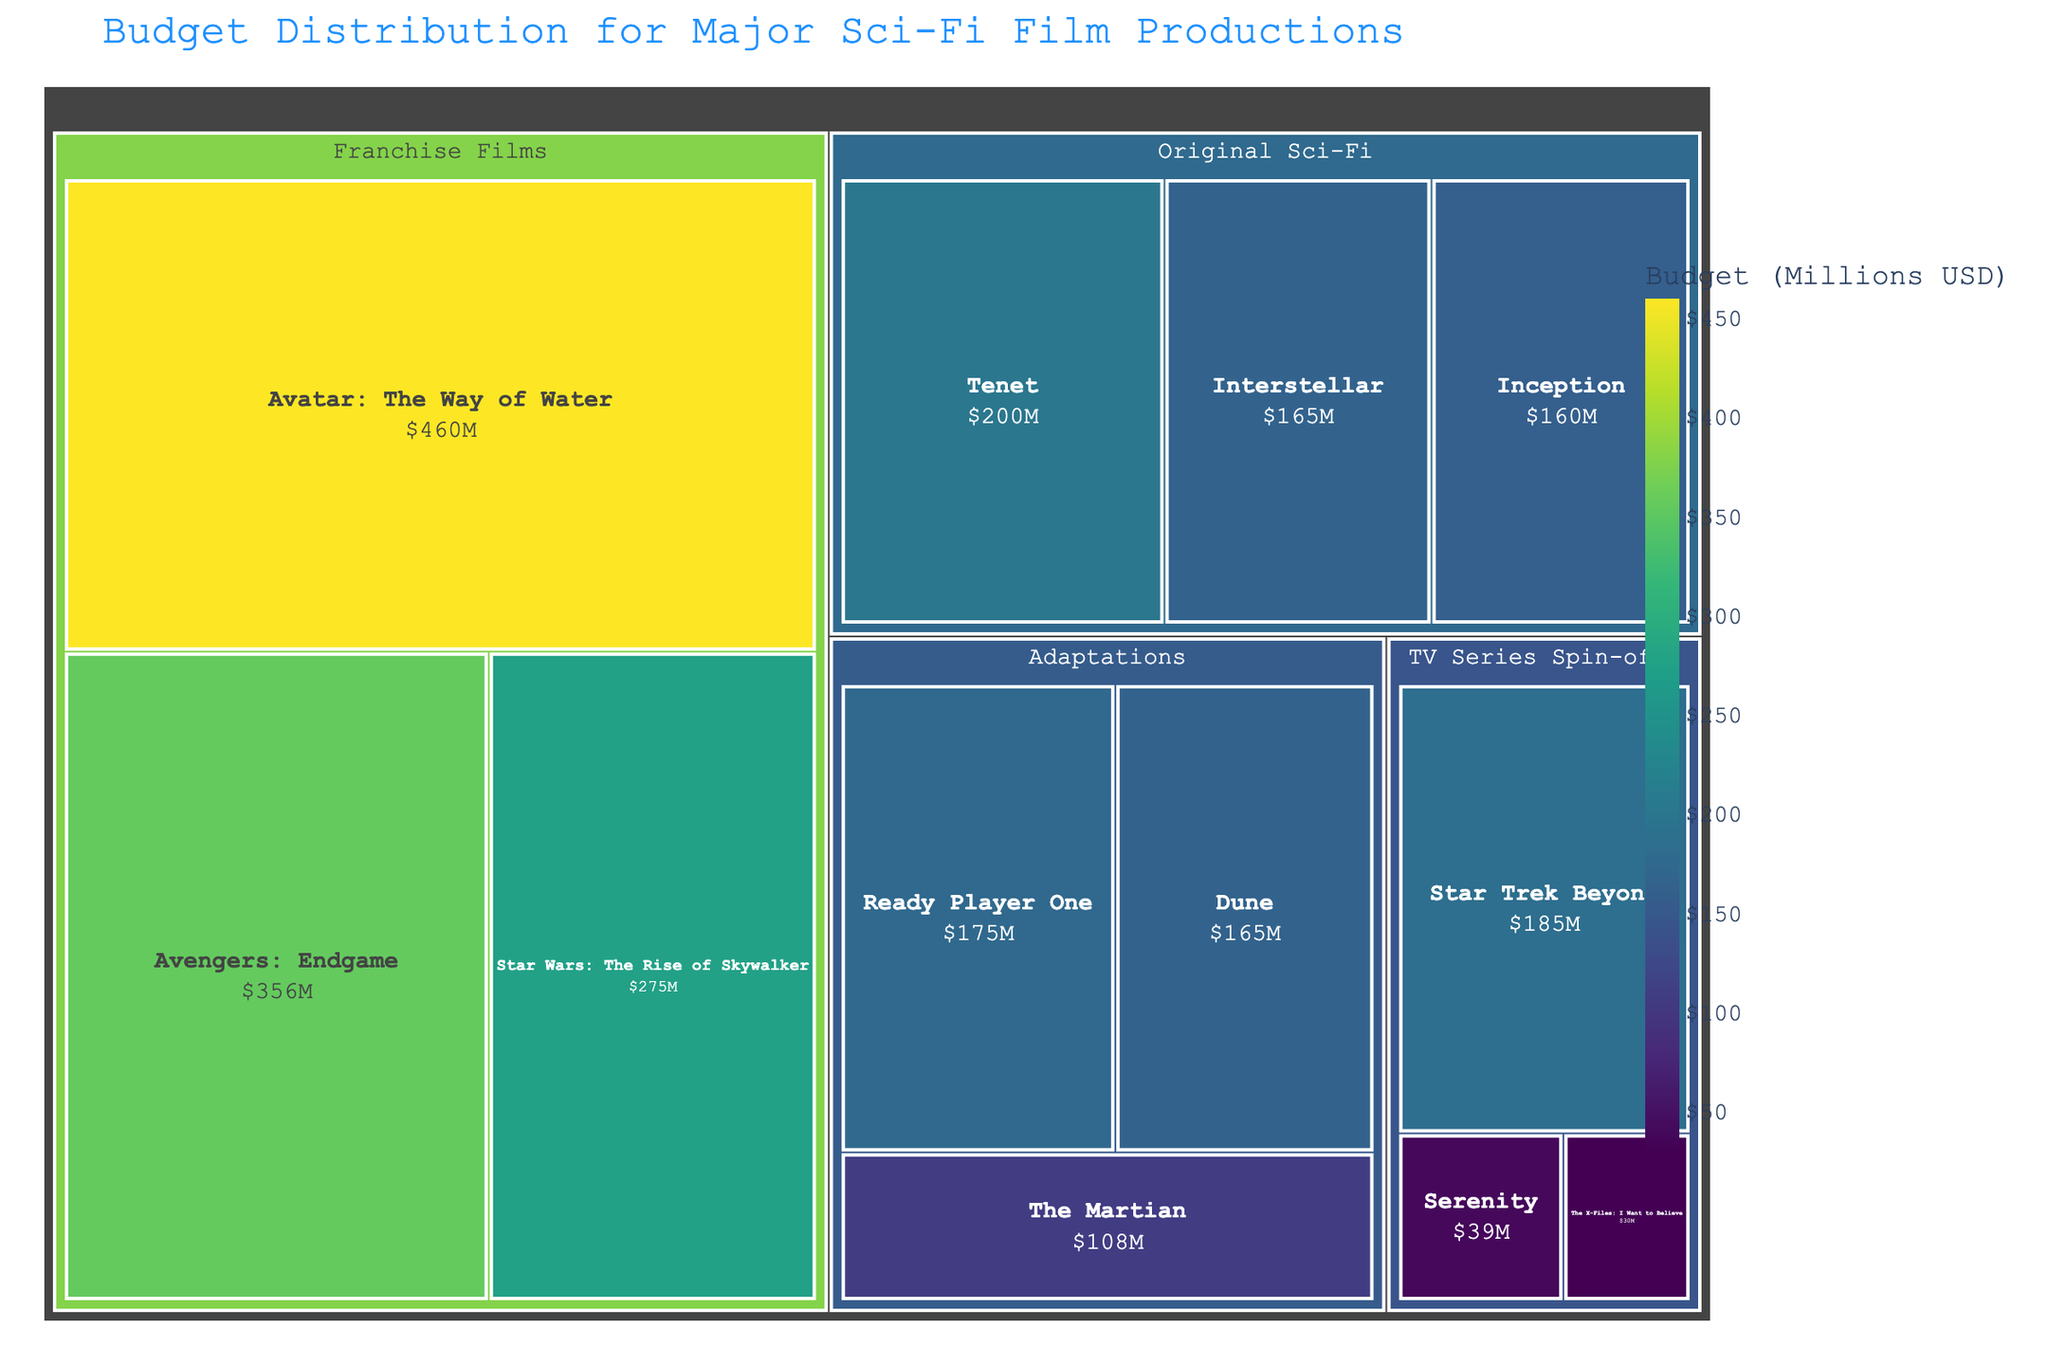What is the title of the Treemap? The title is usually displayed prominently at the top of the Treemap figure. In this case, it helps viewers immediately understand the subject of the visualization without needing to look at the details.
Answer: "Budget Distribution for Major Sci-Fi Film Productions" Which film in the "TV Series Spin-offs" category has the lowest budget? Viewing the treemap, the smallest tile within "TV Series Spin-offs" represents the film with the lowest budget in that category.
Answer: "The X-Files: I Want to Believe" What color scale is used to depict budget values in the Treemap? The color scale is specified by how the values are represented visually. In this case, it utilizes a scale commonly labeled in the figure's legend.
Answer: Viridis What is the budget allocation for "Avatar: The Way of Water"? The budget for each film is shown within the corresponding tile. Locate "Avatar: The Way of Water" in the "Franchise Films" category to get the budget value.
Answer: $460M What is the total budget for films in the "Original Sci-Fi" category? Sum the budget values for all films under the "Original Sci-Fi" category: Interstellar ($165M), Inception ($160M), and Tenet ($200M). Calculate as follows: 165 + 160 + 200.
Answer: $525M Compare the budgets of "Serenity" and "Interstellar". Which film had a higher budget? Locate the tiles for both films on the treemap and compare the budget values displayed on their respective tiles.
Answer: "Interstellar" had a higher budget How does the budget of "The Martian" compare to the budget of "Ready Player One"? Find "The Martian" and "Ready Player One" in the "Adaptations" category and compare their budgets. "The Martian" has a budget of $108M and "Ready Player One" has a budget of $175M.
Answer: "Ready Player One" has a higher budget What is the average budget for the films in the "Adaptations" category? Calculate the average of budgets for "Ready Player One" ($175M), "Dune" ($165M), and "The Martian" ($108M). Sum the values: 175 + 165 + 108 = 448. Then, divide by 3.
Answer: $149.33M Which category has the highest aggregated budget based on the Treemap? Sum the budget values for each category and compare the totals. Franchise Films (275+356+460), Original Sci-Fi (165+160+200), Adaptations (175+165+108), TV Series Spin-offs (185+39+30).
Answer: Franchise Films How many films are there in the "Franchise Films" category? Count the number of tiles beneath the "Franchise Films" section in the Treemap.
Answer: 3 